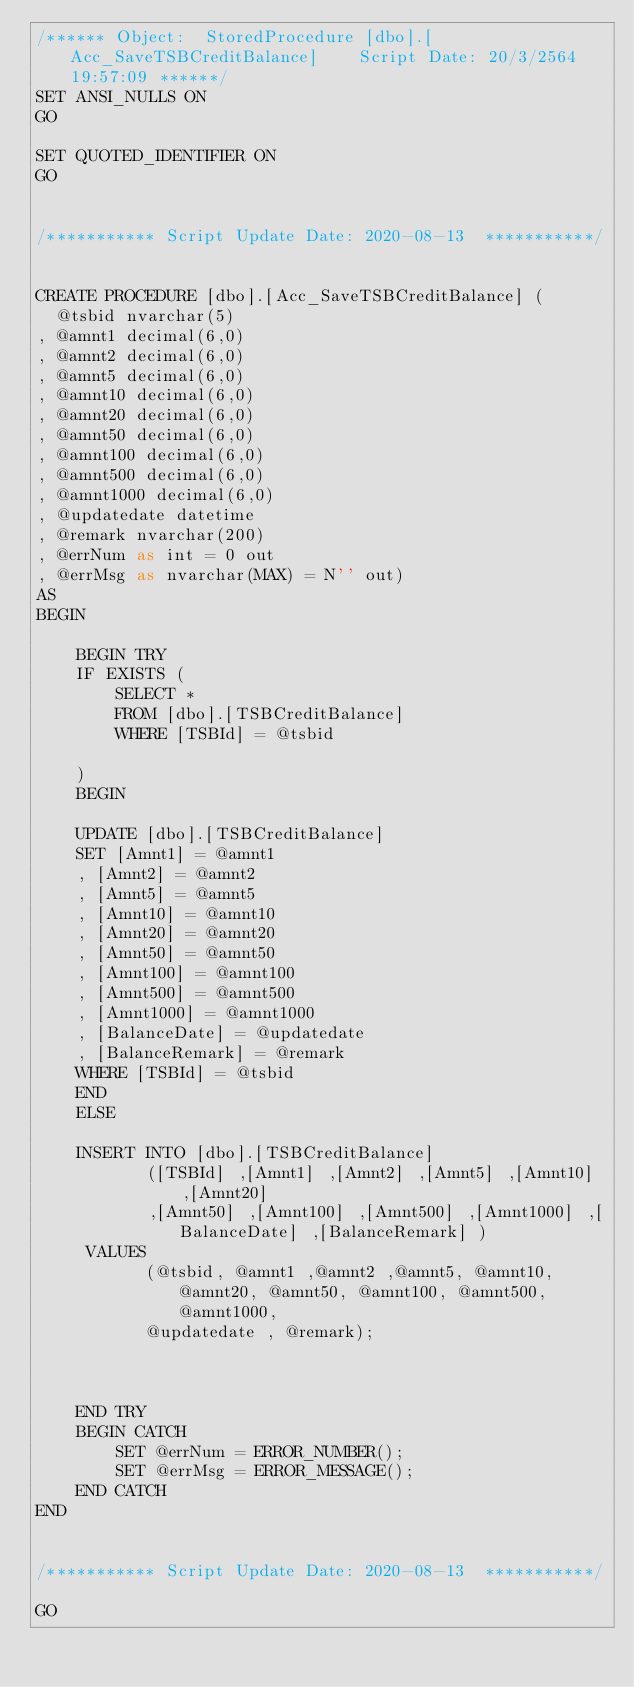<code> <loc_0><loc_0><loc_500><loc_500><_SQL_>/****** Object:  StoredProcedure [dbo].[Acc_SaveTSBCreditBalance]    Script Date: 20/3/2564 19:57:09 ******/
SET ANSI_NULLS ON
GO

SET QUOTED_IDENTIFIER ON
GO


/*********** Script Update Date: 2020-08-13  ***********/


CREATE PROCEDURE [dbo].[Acc_SaveTSBCreditBalance] (
  @tsbid nvarchar(5)
, @amnt1 decimal(6,0)
, @amnt2 decimal(6,0)
, @amnt5 decimal(6,0)
, @amnt10 decimal(6,0)
, @amnt20 decimal(6,0)
, @amnt50 decimal(6,0)
, @amnt100 decimal(6,0)
, @amnt500 decimal(6,0)
, @amnt1000 decimal(6,0)
, @updatedate datetime
, @remark nvarchar(200)
, @errNum as int = 0 out
, @errMsg as nvarchar(MAX) = N'' out)
AS
BEGIN

	BEGIN TRY
	IF EXISTS (
		SELECT *	 
		FROM [dbo].[TSBCreditBalance]
		WHERE [TSBId] = @tsbid
		
	)
	BEGIN

	UPDATE [dbo].[TSBCreditBalance]
	SET [Amnt1] = @amnt1
	, [Amnt2] = @amnt2
	, [Amnt5] = @amnt5
	, [Amnt10] = @amnt10
	, [Amnt20] = @amnt20
	, [Amnt50] = @amnt50
	, [Amnt100] = @amnt100
	, [Amnt500] = @amnt500
	, [Amnt1000] = @amnt1000
	, [BalanceDate] = @updatedate
	, [BalanceRemark] = @remark
    WHERE [TSBId] = @tsbid
	END
	ELSE
		
	INSERT INTO [dbo].[TSBCreditBalance]
           ([TSBId] ,[Amnt1] ,[Amnt2] ,[Amnt5] ,[Amnt10] ,[Amnt20]
           ,[Amnt50] ,[Amnt100] ,[Amnt500] ,[Amnt1000] ,[BalanceDate] ,[BalanceRemark] )
     VALUES
           (@tsbid, @amnt1 ,@amnt2 ,@amnt5, @amnt10, @amnt20, @amnt50, @amnt100, @amnt500, @amnt1000,
		   @updatedate , @remark);


		
	END TRY
	BEGIN CATCH
		SET @errNum = ERROR_NUMBER();
		SET @errMsg = ERROR_MESSAGE();
	END CATCH
END


/*********** Script Update Date: 2020-08-13  ***********/

GO

</code> 